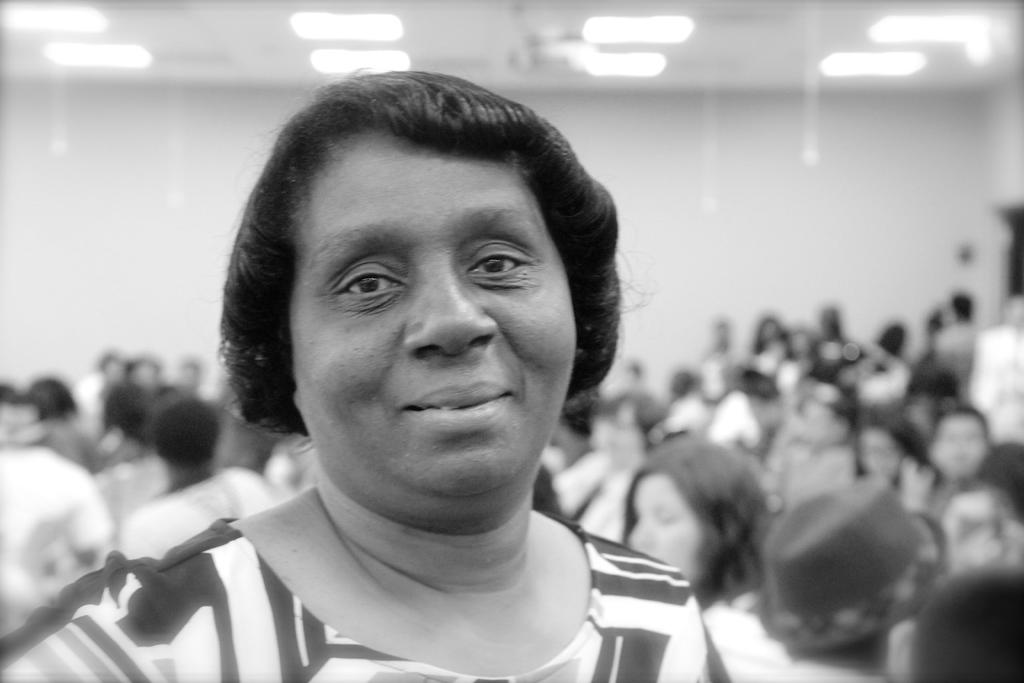What is the color scheme of the image? The image is black and white. How many people can be seen in the image? There are a few people in the image. Can you describe the background of the image? The background of the image is blurred. What type of current can be seen flowing through the gate in the image? There is no gate or current present in the image; it is a black and white image with a few people in it. 